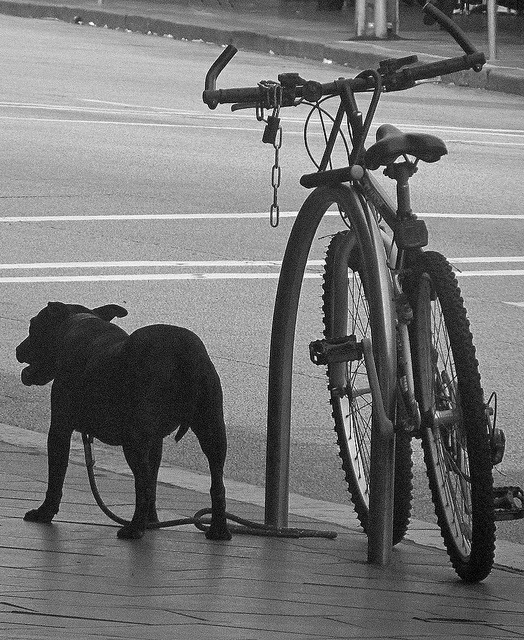Describe the objects in this image and their specific colors. I can see bicycle in gray, black, darkgray, and lightgray tones and dog in gray, black, darkgray, and lightgray tones in this image. 